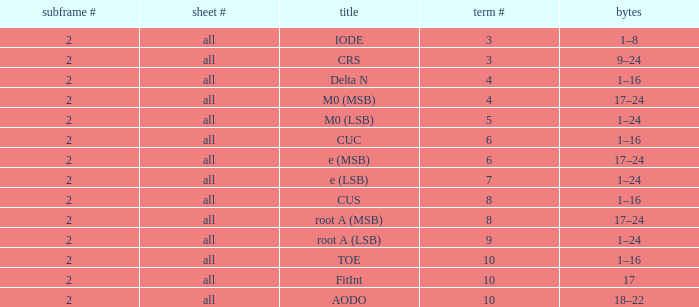Could you parse the entire table? {'header': ['subframe #', 'sheet #', 'title', 'term #', 'bytes'], 'rows': [['2', 'all', 'IODE', '3', '1–8'], ['2', 'all', 'CRS', '3', '9–24'], ['2', 'all', 'Delta N', '4', '1–16'], ['2', 'all', 'M0 (MSB)', '4', '17–24'], ['2', 'all', 'M0 (LSB)', '5', '1–24'], ['2', 'all', 'CUC', '6', '1–16'], ['2', 'all', 'e (MSB)', '6', '17–24'], ['2', 'all', 'e (LSB)', '7', '1–24'], ['2', 'all', 'CUS', '8', '1–16'], ['2', 'all', 'root A (MSB)', '8', '17–24'], ['2', 'all', 'root A (LSB)', '9', '1–24'], ['2', 'all', 'TOE', '10', '1–16'], ['2', 'all', 'FitInt', '10', '17'], ['2', 'all', 'AODO', '10', '18–22']]} What is the page count and word count greater than 5 with Bits of 18–22? All. 